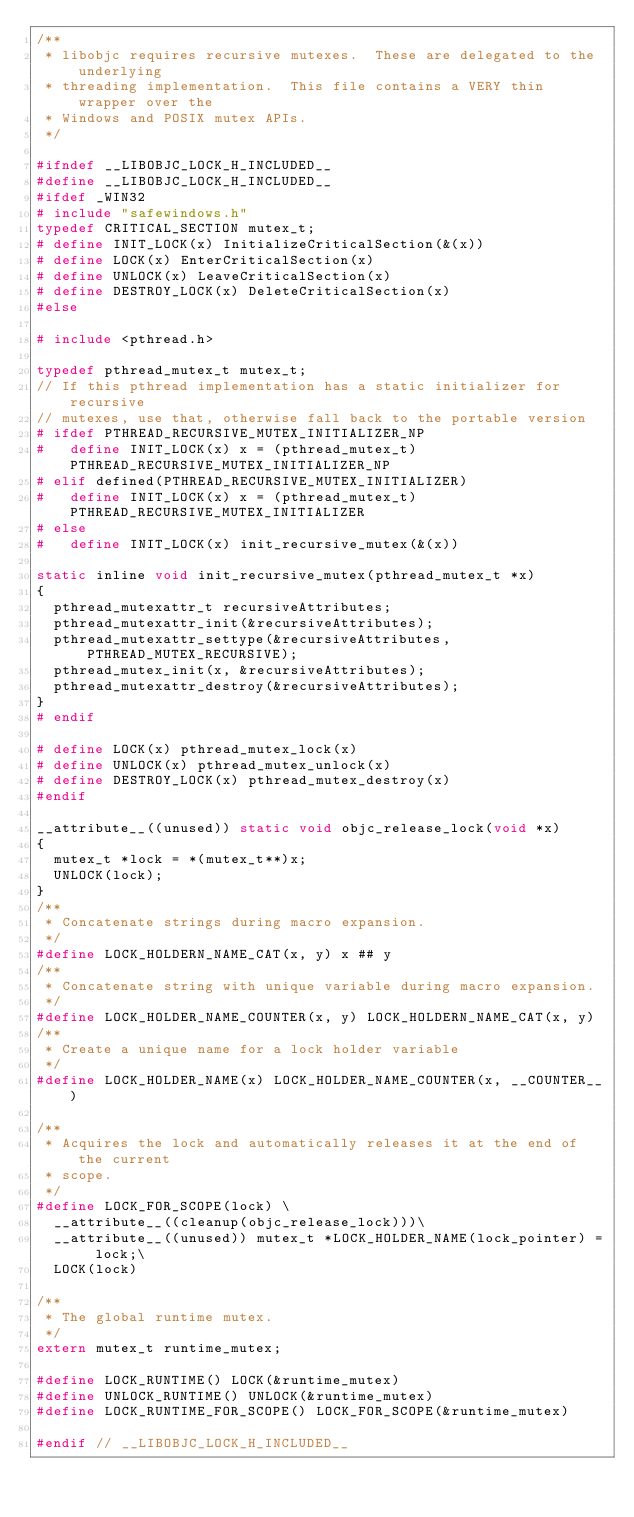<code> <loc_0><loc_0><loc_500><loc_500><_C_>/**
 * libobjc requires recursive mutexes.  These are delegated to the underlying
 * threading implementation.  This file contains a VERY thin wrapper over the
 * Windows and POSIX mutex APIs.
 */

#ifndef __LIBOBJC_LOCK_H_INCLUDED__
#define __LIBOBJC_LOCK_H_INCLUDED__
#ifdef _WIN32
#	include "safewindows.h"
typedef CRITICAL_SECTION mutex_t;
#	define INIT_LOCK(x) InitializeCriticalSection(&(x))
#	define LOCK(x) EnterCriticalSection(x)
#	define UNLOCK(x) LeaveCriticalSection(x)
#	define DESTROY_LOCK(x) DeleteCriticalSection(x)
#else

#	include <pthread.h>

typedef pthread_mutex_t mutex_t;
// If this pthread implementation has a static initializer for recursive
// mutexes, use that, otherwise fall back to the portable version
#	ifdef PTHREAD_RECURSIVE_MUTEX_INITIALIZER_NP
#		define INIT_LOCK(x) x = (pthread_mutex_t)PTHREAD_RECURSIVE_MUTEX_INITIALIZER_NP
#	elif defined(PTHREAD_RECURSIVE_MUTEX_INITIALIZER)
#		define INIT_LOCK(x) x = (pthread_mutex_t)PTHREAD_RECURSIVE_MUTEX_INITIALIZER
#	else
#		define INIT_LOCK(x) init_recursive_mutex(&(x))

static inline void init_recursive_mutex(pthread_mutex_t *x)
{
	pthread_mutexattr_t recursiveAttributes;
	pthread_mutexattr_init(&recursiveAttributes);
	pthread_mutexattr_settype(&recursiveAttributes, PTHREAD_MUTEX_RECURSIVE);
	pthread_mutex_init(x, &recursiveAttributes);
	pthread_mutexattr_destroy(&recursiveAttributes);
}
#	endif

#	define LOCK(x) pthread_mutex_lock(x)
#	define UNLOCK(x) pthread_mutex_unlock(x)
#	define DESTROY_LOCK(x) pthread_mutex_destroy(x)
#endif

__attribute__((unused)) static void objc_release_lock(void *x)
{
	mutex_t *lock = *(mutex_t**)x;
	UNLOCK(lock);
}
/**
 * Concatenate strings during macro expansion.
 */
#define LOCK_HOLDERN_NAME_CAT(x, y) x ## y
/**
 * Concatenate string with unique variable during macro expansion.
 */
#define LOCK_HOLDER_NAME_COUNTER(x, y) LOCK_HOLDERN_NAME_CAT(x, y)
/**
 * Create a unique name for a lock holder variable
 */
#define LOCK_HOLDER_NAME(x) LOCK_HOLDER_NAME_COUNTER(x, __COUNTER__)

/**
 * Acquires the lock and automatically releases it at the end of the current
 * scope.
 */
#define LOCK_FOR_SCOPE(lock) \
	__attribute__((cleanup(objc_release_lock)))\
	__attribute__((unused)) mutex_t *LOCK_HOLDER_NAME(lock_pointer) = lock;\
	LOCK(lock)

/**
 * The global runtime mutex.
 */
extern mutex_t runtime_mutex;

#define LOCK_RUNTIME() LOCK(&runtime_mutex)
#define UNLOCK_RUNTIME() UNLOCK(&runtime_mutex)
#define LOCK_RUNTIME_FOR_SCOPE() LOCK_FOR_SCOPE(&runtime_mutex)

#endif // __LIBOBJC_LOCK_H_INCLUDED__
</code> 